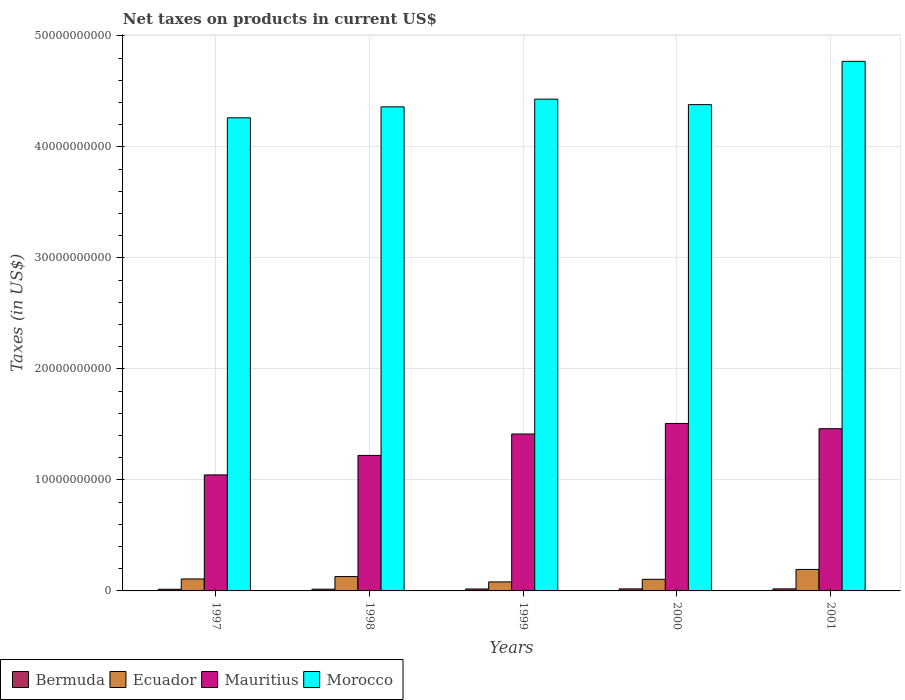How many groups of bars are there?
Give a very brief answer. 5. Are the number of bars per tick equal to the number of legend labels?
Provide a succinct answer. Yes. Are the number of bars on each tick of the X-axis equal?
Keep it short and to the point. Yes. In how many cases, is the number of bars for a given year not equal to the number of legend labels?
Offer a very short reply. 0. What is the net taxes on products in Morocco in 1997?
Your answer should be very brief. 4.26e+1. Across all years, what is the maximum net taxes on products in Ecuador?
Your response must be concise. 1.94e+09. Across all years, what is the minimum net taxes on products in Ecuador?
Ensure brevity in your answer.  8.11e+08. What is the total net taxes on products in Ecuador in the graph?
Give a very brief answer. 6.16e+09. What is the difference between the net taxes on products in Bermuda in 1997 and that in 1999?
Make the answer very short. -2.57e+07. What is the difference between the net taxes on products in Ecuador in 1998 and the net taxes on products in Morocco in 1999?
Give a very brief answer. -4.30e+1. What is the average net taxes on products in Bermuda per year?
Your answer should be very brief. 1.69e+08. In the year 1998, what is the difference between the net taxes on products in Ecuador and net taxes on products in Morocco?
Offer a very short reply. -4.23e+1. In how many years, is the net taxes on products in Ecuador greater than 44000000000 US$?
Provide a succinct answer. 0. What is the ratio of the net taxes on products in Mauritius in 1999 to that in 2001?
Your answer should be very brief. 0.97. Is the net taxes on products in Morocco in 1998 less than that in 2001?
Your response must be concise. Yes. Is the difference between the net taxes on products in Ecuador in 1999 and 2000 greater than the difference between the net taxes on products in Morocco in 1999 and 2000?
Make the answer very short. No. What is the difference between the highest and the second highest net taxes on products in Ecuador?
Provide a short and direct response. 6.43e+08. What is the difference between the highest and the lowest net taxes on products in Ecuador?
Provide a succinct answer. 1.13e+09. Is the sum of the net taxes on products in Ecuador in 1997 and 2001 greater than the maximum net taxes on products in Morocco across all years?
Make the answer very short. No. What does the 2nd bar from the left in 2000 represents?
Provide a succinct answer. Ecuador. What does the 2nd bar from the right in 1998 represents?
Keep it short and to the point. Mauritius. Is it the case that in every year, the sum of the net taxes on products in Mauritius and net taxes on products in Morocco is greater than the net taxes on products in Ecuador?
Provide a short and direct response. Yes. How many bars are there?
Make the answer very short. 20. How many years are there in the graph?
Keep it short and to the point. 5. Are the values on the major ticks of Y-axis written in scientific E-notation?
Your answer should be very brief. No. Does the graph contain any zero values?
Your response must be concise. No. Does the graph contain grids?
Your answer should be compact. Yes. What is the title of the graph?
Provide a short and direct response. Net taxes on products in current US$. Does "Bangladesh" appear as one of the legend labels in the graph?
Your answer should be compact. No. What is the label or title of the Y-axis?
Your answer should be very brief. Taxes (in US$). What is the Taxes (in US$) in Bermuda in 1997?
Ensure brevity in your answer.  1.48e+08. What is the Taxes (in US$) of Ecuador in 1997?
Offer a terse response. 1.08e+09. What is the Taxes (in US$) in Mauritius in 1997?
Keep it short and to the point. 1.05e+1. What is the Taxes (in US$) of Morocco in 1997?
Ensure brevity in your answer.  4.26e+1. What is the Taxes (in US$) in Bermuda in 1998?
Keep it short and to the point. 1.56e+08. What is the Taxes (in US$) in Ecuador in 1998?
Ensure brevity in your answer.  1.29e+09. What is the Taxes (in US$) of Mauritius in 1998?
Make the answer very short. 1.22e+1. What is the Taxes (in US$) of Morocco in 1998?
Make the answer very short. 4.36e+1. What is the Taxes (in US$) in Bermuda in 1999?
Give a very brief answer. 1.74e+08. What is the Taxes (in US$) in Ecuador in 1999?
Ensure brevity in your answer.  8.11e+08. What is the Taxes (in US$) of Mauritius in 1999?
Offer a very short reply. 1.41e+1. What is the Taxes (in US$) of Morocco in 1999?
Your response must be concise. 4.43e+1. What is the Taxes (in US$) in Bermuda in 2000?
Offer a terse response. 1.84e+08. What is the Taxes (in US$) in Ecuador in 2000?
Provide a short and direct response. 1.05e+09. What is the Taxes (in US$) of Mauritius in 2000?
Provide a succinct answer. 1.51e+1. What is the Taxes (in US$) of Morocco in 2000?
Your response must be concise. 4.38e+1. What is the Taxes (in US$) in Bermuda in 2001?
Your response must be concise. 1.85e+08. What is the Taxes (in US$) in Ecuador in 2001?
Your answer should be compact. 1.94e+09. What is the Taxes (in US$) of Mauritius in 2001?
Provide a succinct answer. 1.46e+1. What is the Taxes (in US$) of Morocco in 2001?
Offer a very short reply. 4.77e+1. Across all years, what is the maximum Taxes (in US$) in Bermuda?
Ensure brevity in your answer.  1.85e+08. Across all years, what is the maximum Taxes (in US$) in Ecuador?
Make the answer very short. 1.94e+09. Across all years, what is the maximum Taxes (in US$) of Mauritius?
Make the answer very short. 1.51e+1. Across all years, what is the maximum Taxes (in US$) in Morocco?
Provide a short and direct response. 4.77e+1. Across all years, what is the minimum Taxes (in US$) in Bermuda?
Provide a short and direct response. 1.48e+08. Across all years, what is the minimum Taxes (in US$) of Ecuador?
Give a very brief answer. 8.11e+08. Across all years, what is the minimum Taxes (in US$) in Mauritius?
Your answer should be compact. 1.05e+1. Across all years, what is the minimum Taxes (in US$) in Morocco?
Ensure brevity in your answer.  4.26e+1. What is the total Taxes (in US$) in Bermuda in the graph?
Your answer should be compact. 8.46e+08. What is the total Taxes (in US$) of Ecuador in the graph?
Make the answer very short. 6.16e+09. What is the total Taxes (in US$) in Mauritius in the graph?
Provide a succinct answer. 6.65e+1. What is the total Taxes (in US$) of Morocco in the graph?
Provide a short and direct response. 2.22e+11. What is the difference between the Taxes (in US$) in Bermuda in 1997 and that in 1998?
Provide a short and direct response. -7.57e+06. What is the difference between the Taxes (in US$) in Ecuador in 1997 and that in 1998?
Your response must be concise. -2.14e+08. What is the difference between the Taxes (in US$) in Mauritius in 1997 and that in 1998?
Give a very brief answer. -1.75e+09. What is the difference between the Taxes (in US$) of Morocco in 1997 and that in 1998?
Offer a very short reply. -9.87e+08. What is the difference between the Taxes (in US$) in Bermuda in 1997 and that in 1999?
Make the answer very short. -2.57e+07. What is the difference between the Taxes (in US$) in Ecuador in 1997 and that in 1999?
Keep it short and to the point. 2.68e+08. What is the difference between the Taxes (in US$) in Mauritius in 1997 and that in 1999?
Give a very brief answer. -3.68e+09. What is the difference between the Taxes (in US$) in Morocco in 1997 and that in 1999?
Your answer should be very brief. -1.68e+09. What is the difference between the Taxes (in US$) of Bermuda in 1997 and that in 2000?
Provide a succinct answer. -3.58e+07. What is the difference between the Taxes (in US$) of Ecuador in 1997 and that in 2000?
Provide a short and direct response. 3.25e+07. What is the difference between the Taxes (in US$) of Mauritius in 1997 and that in 2000?
Your answer should be compact. -4.63e+09. What is the difference between the Taxes (in US$) of Morocco in 1997 and that in 2000?
Offer a terse response. -1.19e+09. What is the difference between the Taxes (in US$) of Bermuda in 1997 and that in 2001?
Provide a succinct answer. -3.66e+07. What is the difference between the Taxes (in US$) in Ecuador in 1997 and that in 2001?
Your answer should be compact. -8.58e+08. What is the difference between the Taxes (in US$) in Mauritius in 1997 and that in 2001?
Give a very brief answer. -4.16e+09. What is the difference between the Taxes (in US$) of Morocco in 1997 and that in 2001?
Offer a very short reply. -5.09e+09. What is the difference between the Taxes (in US$) of Bermuda in 1998 and that in 1999?
Keep it short and to the point. -1.81e+07. What is the difference between the Taxes (in US$) in Ecuador in 1998 and that in 1999?
Ensure brevity in your answer.  4.82e+08. What is the difference between the Taxes (in US$) in Mauritius in 1998 and that in 1999?
Make the answer very short. -1.93e+09. What is the difference between the Taxes (in US$) in Morocco in 1998 and that in 1999?
Offer a terse response. -6.94e+08. What is the difference between the Taxes (in US$) in Bermuda in 1998 and that in 2000?
Keep it short and to the point. -2.82e+07. What is the difference between the Taxes (in US$) of Ecuador in 1998 and that in 2000?
Offer a terse response. 2.47e+08. What is the difference between the Taxes (in US$) in Mauritius in 1998 and that in 2000?
Provide a short and direct response. -2.88e+09. What is the difference between the Taxes (in US$) of Morocco in 1998 and that in 2000?
Offer a terse response. -2.01e+08. What is the difference between the Taxes (in US$) in Bermuda in 1998 and that in 2001?
Your answer should be very brief. -2.91e+07. What is the difference between the Taxes (in US$) in Ecuador in 1998 and that in 2001?
Give a very brief answer. -6.43e+08. What is the difference between the Taxes (in US$) of Mauritius in 1998 and that in 2001?
Make the answer very short. -2.41e+09. What is the difference between the Taxes (in US$) of Morocco in 1998 and that in 2001?
Provide a succinct answer. -4.10e+09. What is the difference between the Taxes (in US$) of Bermuda in 1999 and that in 2000?
Your answer should be compact. -1.01e+07. What is the difference between the Taxes (in US$) in Ecuador in 1999 and that in 2000?
Make the answer very short. -2.35e+08. What is the difference between the Taxes (in US$) of Mauritius in 1999 and that in 2000?
Offer a very short reply. -9.49e+08. What is the difference between the Taxes (in US$) of Morocco in 1999 and that in 2000?
Keep it short and to the point. 4.93e+08. What is the difference between the Taxes (in US$) in Bermuda in 1999 and that in 2001?
Your response must be concise. -1.09e+07. What is the difference between the Taxes (in US$) in Ecuador in 1999 and that in 2001?
Give a very brief answer. -1.13e+09. What is the difference between the Taxes (in US$) in Mauritius in 1999 and that in 2001?
Provide a short and direct response. -4.79e+08. What is the difference between the Taxes (in US$) of Morocco in 1999 and that in 2001?
Your answer should be very brief. -3.40e+09. What is the difference between the Taxes (in US$) of Bermuda in 2000 and that in 2001?
Make the answer very short. -8.67e+05. What is the difference between the Taxes (in US$) in Ecuador in 2000 and that in 2001?
Keep it short and to the point. -8.90e+08. What is the difference between the Taxes (in US$) of Mauritius in 2000 and that in 2001?
Offer a very short reply. 4.71e+08. What is the difference between the Taxes (in US$) of Morocco in 2000 and that in 2001?
Ensure brevity in your answer.  -3.90e+09. What is the difference between the Taxes (in US$) in Bermuda in 1997 and the Taxes (in US$) in Ecuador in 1998?
Keep it short and to the point. -1.14e+09. What is the difference between the Taxes (in US$) of Bermuda in 1997 and the Taxes (in US$) of Mauritius in 1998?
Provide a succinct answer. -1.21e+1. What is the difference between the Taxes (in US$) in Bermuda in 1997 and the Taxes (in US$) in Morocco in 1998?
Make the answer very short. -4.35e+1. What is the difference between the Taxes (in US$) in Ecuador in 1997 and the Taxes (in US$) in Mauritius in 1998?
Your response must be concise. -1.11e+1. What is the difference between the Taxes (in US$) in Ecuador in 1997 and the Taxes (in US$) in Morocco in 1998?
Provide a short and direct response. -4.25e+1. What is the difference between the Taxes (in US$) of Mauritius in 1997 and the Taxes (in US$) of Morocco in 1998?
Offer a terse response. -3.32e+1. What is the difference between the Taxes (in US$) in Bermuda in 1997 and the Taxes (in US$) in Ecuador in 1999?
Offer a very short reply. -6.63e+08. What is the difference between the Taxes (in US$) of Bermuda in 1997 and the Taxes (in US$) of Mauritius in 1999?
Ensure brevity in your answer.  -1.40e+1. What is the difference between the Taxes (in US$) in Bermuda in 1997 and the Taxes (in US$) in Morocco in 1999?
Make the answer very short. -4.42e+1. What is the difference between the Taxes (in US$) of Ecuador in 1997 and the Taxes (in US$) of Mauritius in 1999?
Offer a terse response. -1.31e+1. What is the difference between the Taxes (in US$) in Ecuador in 1997 and the Taxes (in US$) in Morocco in 1999?
Keep it short and to the point. -4.32e+1. What is the difference between the Taxes (in US$) in Mauritius in 1997 and the Taxes (in US$) in Morocco in 1999?
Your response must be concise. -3.38e+1. What is the difference between the Taxes (in US$) in Bermuda in 1997 and the Taxes (in US$) in Ecuador in 2000?
Offer a very short reply. -8.98e+08. What is the difference between the Taxes (in US$) of Bermuda in 1997 and the Taxes (in US$) of Mauritius in 2000?
Give a very brief answer. -1.49e+1. What is the difference between the Taxes (in US$) in Bermuda in 1997 and the Taxes (in US$) in Morocco in 2000?
Your answer should be very brief. -4.37e+1. What is the difference between the Taxes (in US$) in Ecuador in 1997 and the Taxes (in US$) in Mauritius in 2000?
Give a very brief answer. -1.40e+1. What is the difference between the Taxes (in US$) in Ecuador in 1997 and the Taxes (in US$) in Morocco in 2000?
Provide a succinct answer. -4.27e+1. What is the difference between the Taxes (in US$) of Mauritius in 1997 and the Taxes (in US$) of Morocco in 2000?
Provide a short and direct response. -3.34e+1. What is the difference between the Taxes (in US$) in Bermuda in 1997 and the Taxes (in US$) in Ecuador in 2001?
Your answer should be very brief. -1.79e+09. What is the difference between the Taxes (in US$) of Bermuda in 1997 and the Taxes (in US$) of Mauritius in 2001?
Offer a terse response. -1.45e+1. What is the difference between the Taxes (in US$) of Bermuda in 1997 and the Taxes (in US$) of Morocco in 2001?
Ensure brevity in your answer.  -4.76e+1. What is the difference between the Taxes (in US$) in Ecuador in 1997 and the Taxes (in US$) in Mauritius in 2001?
Ensure brevity in your answer.  -1.35e+1. What is the difference between the Taxes (in US$) of Ecuador in 1997 and the Taxes (in US$) of Morocco in 2001?
Provide a short and direct response. -4.66e+1. What is the difference between the Taxes (in US$) of Mauritius in 1997 and the Taxes (in US$) of Morocco in 2001?
Offer a very short reply. -3.73e+1. What is the difference between the Taxes (in US$) of Bermuda in 1998 and the Taxes (in US$) of Ecuador in 1999?
Offer a terse response. -6.55e+08. What is the difference between the Taxes (in US$) of Bermuda in 1998 and the Taxes (in US$) of Mauritius in 1999?
Your answer should be compact. -1.40e+1. What is the difference between the Taxes (in US$) of Bermuda in 1998 and the Taxes (in US$) of Morocco in 1999?
Ensure brevity in your answer.  -4.41e+1. What is the difference between the Taxes (in US$) of Ecuador in 1998 and the Taxes (in US$) of Mauritius in 1999?
Offer a terse response. -1.28e+1. What is the difference between the Taxes (in US$) of Ecuador in 1998 and the Taxes (in US$) of Morocco in 1999?
Offer a very short reply. -4.30e+1. What is the difference between the Taxes (in US$) in Mauritius in 1998 and the Taxes (in US$) in Morocco in 1999?
Keep it short and to the point. -3.21e+1. What is the difference between the Taxes (in US$) of Bermuda in 1998 and the Taxes (in US$) of Ecuador in 2000?
Provide a short and direct response. -8.90e+08. What is the difference between the Taxes (in US$) in Bermuda in 1998 and the Taxes (in US$) in Mauritius in 2000?
Provide a succinct answer. -1.49e+1. What is the difference between the Taxes (in US$) of Bermuda in 1998 and the Taxes (in US$) of Morocco in 2000?
Give a very brief answer. -4.37e+1. What is the difference between the Taxes (in US$) in Ecuador in 1998 and the Taxes (in US$) in Mauritius in 2000?
Keep it short and to the point. -1.38e+1. What is the difference between the Taxes (in US$) of Ecuador in 1998 and the Taxes (in US$) of Morocco in 2000?
Offer a very short reply. -4.25e+1. What is the difference between the Taxes (in US$) in Mauritius in 1998 and the Taxes (in US$) in Morocco in 2000?
Keep it short and to the point. -3.16e+1. What is the difference between the Taxes (in US$) of Bermuda in 1998 and the Taxes (in US$) of Ecuador in 2001?
Provide a short and direct response. -1.78e+09. What is the difference between the Taxes (in US$) in Bermuda in 1998 and the Taxes (in US$) in Mauritius in 2001?
Keep it short and to the point. -1.45e+1. What is the difference between the Taxes (in US$) of Bermuda in 1998 and the Taxes (in US$) of Morocco in 2001?
Provide a short and direct response. -4.75e+1. What is the difference between the Taxes (in US$) of Ecuador in 1998 and the Taxes (in US$) of Mauritius in 2001?
Provide a short and direct response. -1.33e+1. What is the difference between the Taxes (in US$) of Ecuador in 1998 and the Taxes (in US$) of Morocco in 2001?
Ensure brevity in your answer.  -4.64e+1. What is the difference between the Taxes (in US$) in Mauritius in 1998 and the Taxes (in US$) in Morocco in 2001?
Provide a short and direct response. -3.55e+1. What is the difference between the Taxes (in US$) in Bermuda in 1999 and the Taxes (in US$) in Ecuador in 2000?
Give a very brief answer. -8.72e+08. What is the difference between the Taxes (in US$) of Bermuda in 1999 and the Taxes (in US$) of Mauritius in 2000?
Your answer should be compact. -1.49e+1. What is the difference between the Taxes (in US$) of Bermuda in 1999 and the Taxes (in US$) of Morocco in 2000?
Make the answer very short. -4.36e+1. What is the difference between the Taxes (in US$) of Ecuador in 1999 and the Taxes (in US$) of Mauritius in 2000?
Make the answer very short. -1.43e+1. What is the difference between the Taxes (in US$) in Ecuador in 1999 and the Taxes (in US$) in Morocco in 2000?
Keep it short and to the point. -4.30e+1. What is the difference between the Taxes (in US$) of Mauritius in 1999 and the Taxes (in US$) of Morocco in 2000?
Your answer should be very brief. -2.97e+1. What is the difference between the Taxes (in US$) in Bermuda in 1999 and the Taxes (in US$) in Ecuador in 2001?
Your answer should be compact. -1.76e+09. What is the difference between the Taxes (in US$) in Bermuda in 1999 and the Taxes (in US$) in Mauritius in 2001?
Your answer should be compact. -1.44e+1. What is the difference between the Taxes (in US$) in Bermuda in 1999 and the Taxes (in US$) in Morocco in 2001?
Keep it short and to the point. -4.75e+1. What is the difference between the Taxes (in US$) of Ecuador in 1999 and the Taxes (in US$) of Mauritius in 2001?
Provide a succinct answer. -1.38e+1. What is the difference between the Taxes (in US$) of Ecuador in 1999 and the Taxes (in US$) of Morocco in 2001?
Provide a succinct answer. -4.69e+1. What is the difference between the Taxes (in US$) in Mauritius in 1999 and the Taxes (in US$) in Morocco in 2001?
Your answer should be compact. -3.36e+1. What is the difference between the Taxes (in US$) in Bermuda in 2000 and the Taxes (in US$) in Ecuador in 2001?
Keep it short and to the point. -1.75e+09. What is the difference between the Taxes (in US$) of Bermuda in 2000 and the Taxes (in US$) of Mauritius in 2001?
Give a very brief answer. -1.44e+1. What is the difference between the Taxes (in US$) of Bermuda in 2000 and the Taxes (in US$) of Morocco in 2001?
Give a very brief answer. -4.75e+1. What is the difference between the Taxes (in US$) of Ecuador in 2000 and the Taxes (in US$) of Mauritius in 2001?
Keep it short and to the point. -1.36e+1. What is the difference between the Taxes (in US$) in Ecuador in 2000 and the Taxes (in US$) in Morocco in 2001?
Make the answer very short. -4.67e+1. What is the difference between the Taxes (in US$) of Mauritius in 2000 and the Taxes (in US$) of Morocco in 2001?
Your answer should be compact. -3.26e+1. What is the average Taxes (in US$) of Bermuda per year?
Ensure brevity in your answer.  1.69e+08. What is the average Taxes (in US$) of Ecuador per year?
Offer a terse response. 1.23e+09. What is the average Taxes (in US$) in Mauritius per year?
Make the answer very short. 1.33e+1. What is the average Taxes (in US$) in Morocco per year?
Your answer should be compact. 4.44e+1. In the year 1997, what is the difference between the Taxes (in US$) of Bermuda and Taxes (in US$) of Ecuador?
Your answer should be compact. -9.30e+08. In the year 1997, what is the difference between the Taxes (in US$) of Bermuda and Taxes (in US$) of Mauritius?
Provide a short and direct response. -1.03e+1. In the year 1997, what is the difference between the Taxes (in US$) of Bermuda and Taxes (in US$) of Morocco?
Offer a terse response. -4.25e+1. In the year 1997, what is the difference between the Taxes (in US$) in Ecuador and Taxes (in US$) in Mauritius?
Offer a terse response. -9.37e+09. In the year 1997, what is the difference between the Taxes (in US$) of Ecuador and Taxes (in US$) of Morocco?
Offer a terse response. -4.15e+1. In the year 1997, what is the difference between the Taxes (in US$) of Mauritius and Taxes (in US$) of Morocco?
Your response must be concise. -3.22e+1. In the year 1998, what is the difference between the Taxes (in US$) of Bermuda and Taxes (in US$) of Ecuador?
Your answer should be compact. -1.14e+09. In the year 1998, what is the difference between the Taxes (in US$) of Bermuda and Taxes (in US$) of Mauritius?
Give a very brief answer. -1.21e+1. In the year 1998, what is the difference between the Taxes (in US$) in Bermuda and Taxes (in US$) in Morocco?
Your response must be concise. -4.34e+1. In the year 1998, what is the difference between the Taxes (in US$) of Ecuador and Taxes (in US$) of Mauritius?
Offer a very short reply. -1.09e+1. In the year 1998, what is the difference between the Taxes (in US$) in Ecuador and Taxes (in US$) in Morocco?
Keep it short and to the point. -4.23e+1. In the year 1998, what is the difference between the Taxes (in US$) of Mauritius and Taxes (in US$) of Morocco?
Keep it short and to the point. -3.14e+1. In the year 1999, what is the difference between the Taxes (in US$) of Bermuda and Taxes (in US$) of Ecuador?
Provide a short and direct response. -6.37e+08. In the year 1999, what is the difference between the Taxes (in US$) in Bermuda and Taxes (in US$) in Mauritius?
Offer a very short reply. -1.40e+1. In the year 1999, what is the difference between the Taxes (in US$) of Bermuda and Taxes (in US$) of Morocco?
Offer a terse response. -4.41e+1. In the year 1999, what is the difference between the Taxes (in US$) of Ecuador and Taxes (in US$) of Mauritius?
Keep it short and to the point. -1.33e+1. In the year 1999, what is the difference between the Taxes (in US$) in Ecuador and Taxes (in US$) in Morocco?
Your response must be concise. -4.35e+1. In the year 1999, what is the difference between the Taxes (in US$) in Mauritius and Taxes (in US$) in Morocco?
Your answer should be compact. -3.02e+1. In the year 2000, what is the difference between the Taxes (in US$) in Bermuda and Taxes (in US$) in Ecuador?
Offer a very short reply. -8.62e+08. In the year 2000, what is the difference between the Taxes (in US$) of Bermuda and Taxes (in US$) of Mauritius?
Your response must be concise. -1.49e+1. In the year 2000, what is the difference between the Taxes (in US$) of Bermuda and Taxes (in US$) of Morocco?
Your answer should be very brief. -4.36e+1. In the year 2000, what is the difference between the Taxes (in US$) of Ecuador and Taxes (in US$) of Mauritius?
Provide a succinct answer. -1.40e+1. In the year 2000, what is the difference between the Taxes (in US$) of Ecuador and Taxes (in US$) of Morocco?
Make the answer very short. -4.28e+1. In the year 2000, what is the difference between the Taxes (in US$) of Mauritius and Taxes (in US$) of Morocco?
Provide a short and direct response. -2.87e+1. In the year 2001, what is the difference between the Taxes (in US$) of Bermuda and Taxes (in US$) of Ecuador?
Your response must be concise. -1.75e+09. In the year 2001, what is the difference between the Taxes (in US$) in Bermuda and Taxes (in US$) in Mauritius?
Your answer should be compact. -1.44e+1. In the year 2001, what is the difference between the Taxes (in US$) in Bermuda and Taxes (in US$) in Morocco?
Offer a terse response. -4.75e+1. In the year 2001, what is the difference between the Taxes (in US$) in Ecuador and Taxes (in US$) in Mauritius?
Offer a very short reply. -1.27e+1. In the year 2001, what is the difference between the Taxes (in US$) of Ecuador and Taxes (in US$) of Morocco?
Keep it short and to the point. -4.58e+1. In the year 2001, what is the difference between the Taxes (in US$) in Mauritius and Taxes (in US$) in Morocco?
Make the answer very short. -3.31e+1. What is the ratio of the Taxes (in US$) of Bermuda in 1997 to that in 1998?
Your answer should be compact. 0.95. What is the ratio of the Taxes (in US$) in Ecuador in 1997 to that in 1998?
Your answer should be compact. 0.83. What is the ratio of the Taxes (in US$) in Mauritius in 1997 to that in 1998?
Your response must be concise. 0.86. What is the ratio of the Taxes (in US$) of Morocco in 1997 to that in 1998?
Provide a short and direct response. 0.98. What is the ratio of the Taxes (in US$) of Bermuda in 1997 to that in 1999?
Your answer should be compact. 0.85. What is the ratio of the Taxes (in US$) of Ecuador in 1997 to that in 1999?
Ensure brevity in your answer.  1.33. What is the ratio of the Taxes (in US$) in Mauritius in 1997 to that in 1999?
Your answer should be compact. 0.74. What is the ratio of the Taxes (in US$) in Morocco in 1997 to that in 1999?
Provide a short and direct response. 0.96. What is the ratio of the Taxes (in US$) in Bermuda in 1997 to that in 2000?
Offer a very short reply. 0.81. What is the ratio of the Taxes (in US$) of Ecuador in 1997 to that in 2000?
Give a very brief answer. 1.03. What is the ratio of the Taxes (in US$) of Mauritius in 1997 to that in 2000?
Your answer should be very brief. 0.69. What is the ratio of the Taxes (in US$) of Morocco in 1997 to that in 2000?
Your answer should be compact. 0.97. What is the ratio of the Taxes (in US$) of Bermuda in 1997 to that in 2001?
Your answer should be compact. 0.8. What is the ratio of the Taxes (in US$) of Ecuador in 1997 to that in 2001?
Keep it short and to the point. 0.56. What is the ratio of the Taxes (in US$) of Mauritius in 1997 to that in 2001?
Keep it short and to the point. 0.72. What is the ratio of the Taxes (in US$) of Morocco in 1997 to that in 2001?
Keep it short and to the point. 0.89. What is the ratio of the Taxes (in US$) of Bermuda in 1998 to that in 1999?
Your answer should be very brief. 0.9. What is the ratio of the Taxes (in US$) in Ecuador in 1998 to that in 1999?
Provide a succinct answer. 1.59. What is the ratio of the Taxes (in US$) in Mauritius in 1998 to that in 1999?
Make the answer very short. 0.86. What is the ratio of the Taxes (in US$) in Morocco in 1998 to that in 1999?
Make the answer very short. 0.98. What is the ratio of the Taxes (in US$) in Bermuda in 1998 to that in 2000?
Ensure brevity in your answer.  0.85. What is the ratio of the Taxes (in US$) in Ecuador in 1998 to that in 2000?
Ensure brevity in your answer.  1.24. What is the ratio of the Taxes (in US$) in Mauritius in 1998 to that in 2000?
Offer a terse response. 0.81. What is the ratio of the Taxes (in US$) of Morocco in 1998 to that in 2000?
Offer a terse response. 1. What is the ratio of the Taxes (in US$) in Bermuda in 1998 to that in 2001?
Your answer should be very brief. 0.84. What is the ratio of the Taxes (in US$) in Ecuador in 1998 to that in 2001?
Give a very brief answer. 0.67. What is the ratio of the Taxes (in US$) of Mauritius in 1998 to that in 2001?
Offer a terse response. 0.84. What is the ratio of the Taxes (in US$) of Morocco in 1998 to that in 2001?
Keep it short and to the point. 0.91. What is the ratio of the Taxes (in US$) in Bermuda in 1999 to that in 2000?
Keep it short and to the point. 0.95. What is the ratio of the Taxes (in US$) of Ecuador in 1999 to that in 2000?
Offer a terse response. 0.78. What is the ratio of the Taxes (in US$) of Mauritius in 1999 to that in 2000?
Your response must be concise. 0.94. What is the ratio of the Taxes (in US$) of Morocco in 1999 to that in 2000?
Provide a succinct answer. 1.01. What is the ratio of the Taxes (in US$) of Bermuda in 1999 to that in 2001?
Provide a short and direct response. 0.94. What is the ratio of the Taxes (in US$) of Ecuador in 1999 to that in 2001?
Provide a short and direct response. 0.42. What is the ratio of the Taxes (in US$) of Mauritius in 1999 to that in 2001?
Your answer should be very brief. 0.97. What is the ratio of the Taxes (in US$) in Ecuador in 2000 to that in 2001?
Ensure brevity in your answer.  0.54. What is the ratio of the Taxes (in US$) in Mauritius in 2000 to that in 2001?
Keep it short and to the point. 1.03. What is the ratio of the Taxes (in US$) in Morocco in 2000 to that in 2001?
Ensure brevity in your answer.  0.92. What is the difference between the highest and the second highest Taxes (in US$) of Bermuda?
Your answer should be very brief. 8.67e+05. What is the difference between the highest and the second highest Taxes (in US$) in Ecuador?
Your answer should be compact. 6.43e+08. What is the difference between the highest and the second highest Taxes (in US$) of Mauritius?
Your answer should be compact. 4.71e+08. What is the difference between the highest and the second highest Taxes (in US$) of Morocco?
Provide a short and direct response. 3.40e+09. What is the difference between the highest and the lowest Taxes (in US$) of Bermuda?
Offer a very short reply. 3.66e+07. What is the difference between the highest and the lowest Taxes (in US$) of Ecuador?
Keep it short and to the point. 1.13e+09. What is the difference between the highest and the lowest Taxes (in US$) of Mauritius?
Ensure brevity in your answer.  4.63e+09. What is the difference between the highest and the lowest Taxes (in US$) of Morocco?
Provide a short and direct response. 5.09e+09. 